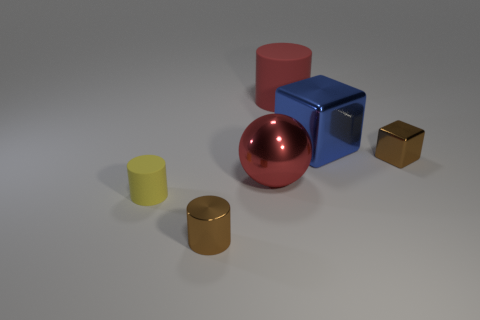Add 3 purple matte cylinders. How many objects exist? 9 Subtract all spheres. How many objects are left? 5 Subtract 1 red cylinders. How many objects are left? 5 Subtract all metallic objects. Subtract all cyan shiny objects. How many objects are left? 2 Add 1 blue metal blocks. How many blue metal blocks are left? 2 Add 6 purple things. How many purple things exist? 6 